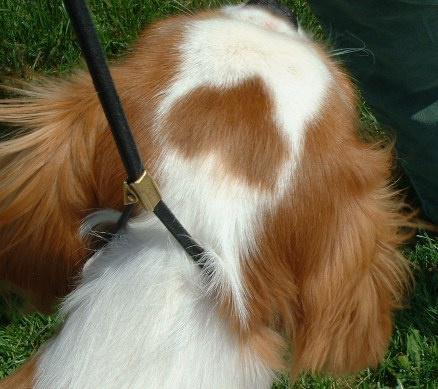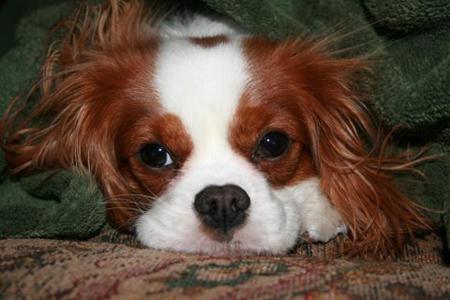The first image is the image on the left, the second image is the image on the right. Examine the images to the left and right. Is the description "Right and left images contain the same number of spaniels, and all dogs are turned mostly frontward." accurate? Answer yes or no. No. The first image is the image on the left, the second image is the image on the right. Given the left and right images, does the statement "An image contains a dog attached to a leash." hold true? Answer yes or no. Yes. 